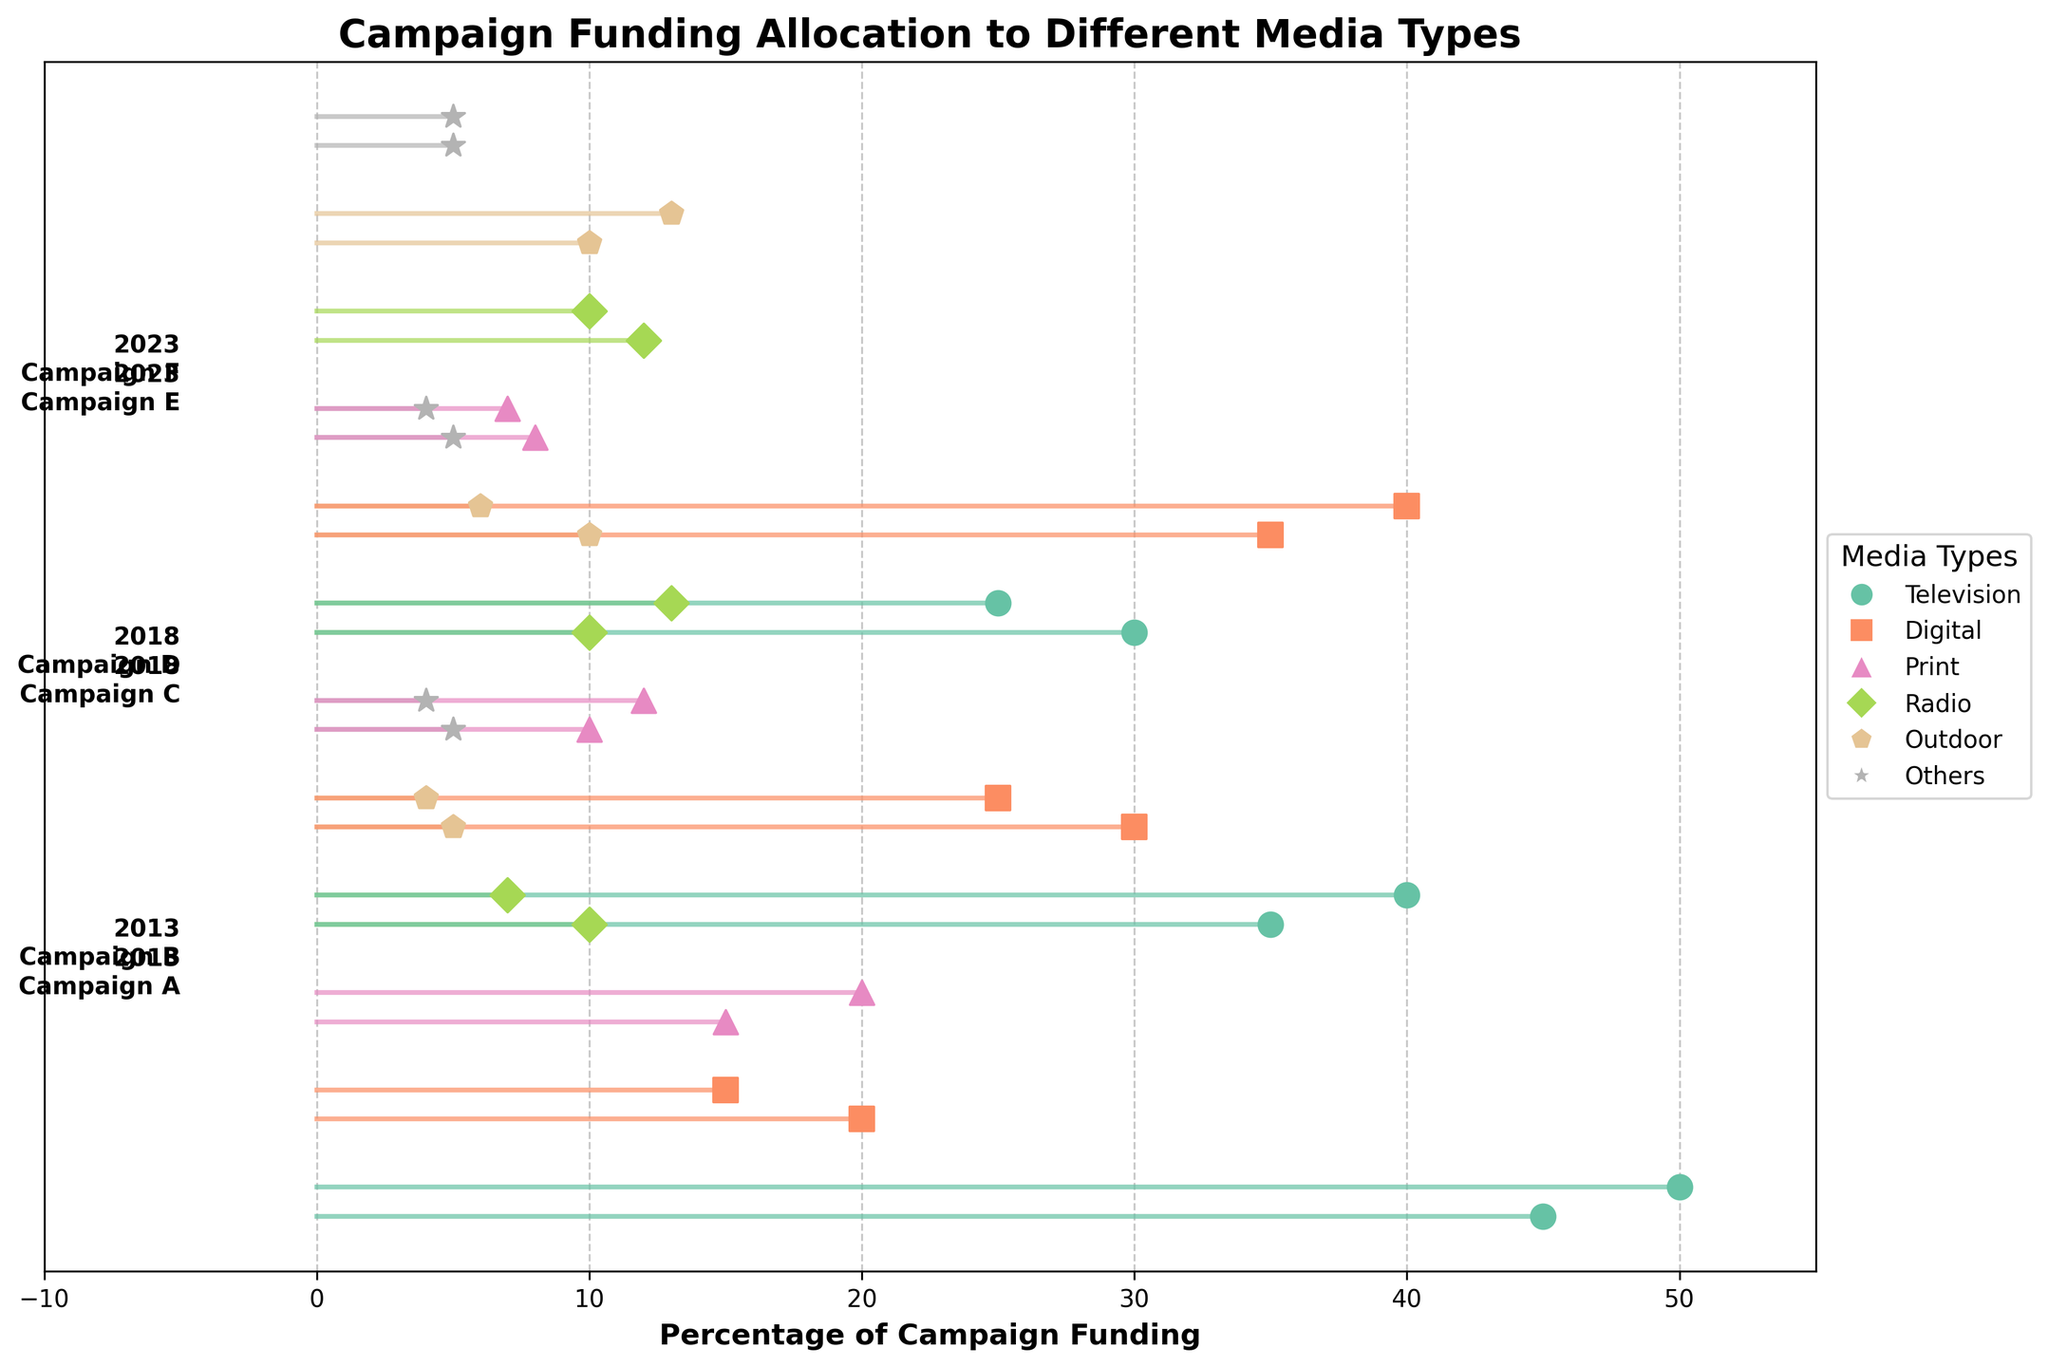What is the title of the plot? The title is usually displayed at the top of the figure, and it provides a summary of the data being visualized.
Answer: "Campaign Funding Allocation to Different Media Types" What is the percentage of campaign funding allocated to Television for Campaign B in 2013? Locate Campaign B for the year 2013, and find the line corresponding to Television.
Answer: 50% Which media type saw an increase in campaign funding from 2013 to 2023 for Campaign F? Compare the values for different media types in Campaign F between 2013 and 2023. Observe that Digital media shows an increase.
Answer: Digital What is the total percentage of funding for Print and Radio in Campaign C in 2018? Locate Campaign C in 2018 and sum the percentages for Print and Radio. Print is 10%, and Radio is 10%, so 10 + 10 = 20%.
Answer: 20% Which campaign in 2023 allocated the highest percentage of their funding to Digital media? Compare the Digital media percentages for all campaigns in 2023. Campaign F allocates 40% to Digital media, which is the highest.
Answer: Campaign F How has the percentage of funding for Television changed for Campaign A from 2013 to 2023? Compare the percentage for Television for Campaign A in 2013 (45%) to the percentage in 2023 (30%). The percentage decreased by 15%.
Answer: Decreased by 15% What is the average percentage of funding allocated to Outdoor media across all campaigns in 2018? Sum the Outdoor funding percentages for all campaigns in 2018 and divide by the number of campaigns that year. (10 + 6) / 2 = 8%.
Answer: 8% Which year and campaign shows the smallest percentage of funding allocated to Others media? Find the smallest percentage for Others across all years and campaigns. Locate the smallest value of 4% in Campaign B, 2013; Campaign D, 2018; and Campaign F, 2023.
Answer: 2013 Campaign B, 2018 Campaign D, 2023 Campaign F (tie) What is the difference in percentage allocation to Digital media between Campaign E and Campaign F in 2023? Compare the Digital media percentages for Campaign E (35%) and Campaign F (40%). The difference is 5%.
Answer: 5% How does the funding allocation for Print in Campaign C compare with Campaign E in 2023? Compare the Print percentages in Campaign C (2018) which is 10% with Campaign E (2023) which is 8%. Print funding decreased by 2%.
Answer: Decreased by 2% 